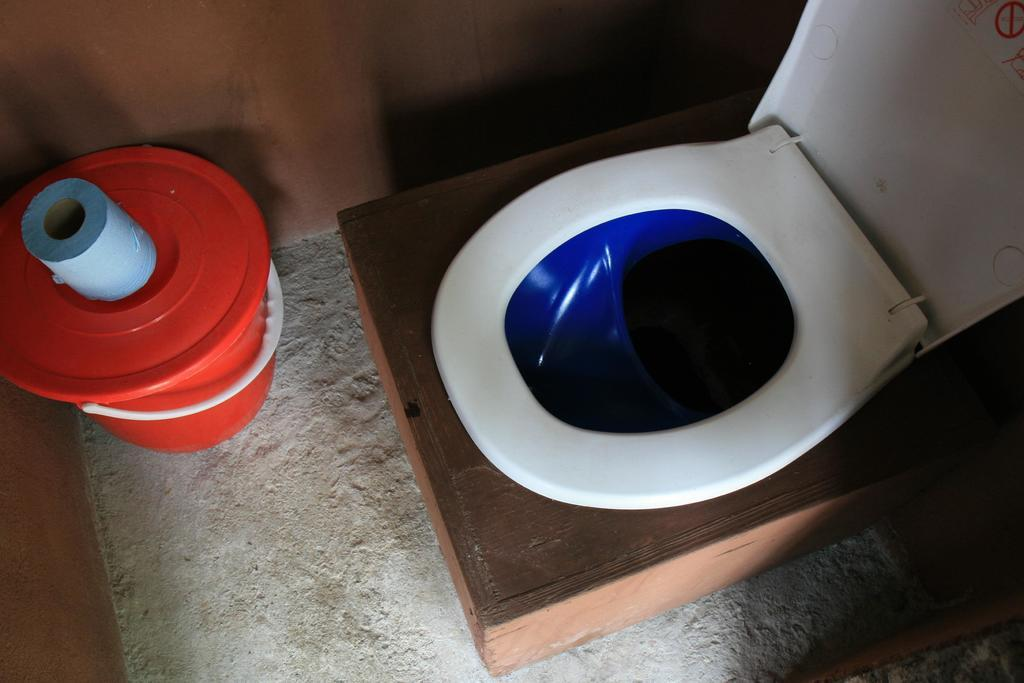What is the main object in the image? There is a toilet seat in the image. What colors are used for the toilet seat? The toilet seat is in white and blue color. What other object can be seen in the image? There is a bucket in the image. What color is the bucket? The bucket is in red color. What type of surprise can be seen in the image? There is no surprise present in the image; it features a toilet seat and a bucket with specific colors. How does the toilet seat look at the person in the image? The image does not show a person, so it is not possible to determine how the toilet seat looks at a person. 